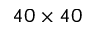<formula> <loc_0><loc_0><loc_500><loc_500>4 0 \times 4 0</formula> 